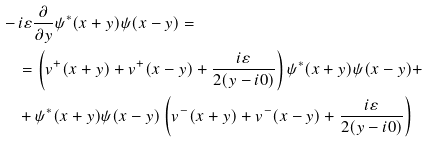Convert formula to latex. <formula><loc_0><loc_0><loc_500><loc_500>& - i \varepsilon \frac { \partial } { \partial y } \psi ^ { * } ( x + y ) \psi ( x - y ) = \\ & \quad = \left ( v ^ { + } ( x + y ) + v ^ { + } ( x - y ) + \frac { i \varepsilon } { 2 ( y - i 0 ) } \right ) \psi ^ { * } ( x + y ) \psi ( x - y ) + \\ & \quad + \psi ^ { * } ( x + y ) \psi ( x - y ) \left ( v ^ { - } ( x + y ) + v ^ { - } ( x - y ) + \frac { i \varepsilon } { 2 ( y - i 0 ) } \right )</formula> 